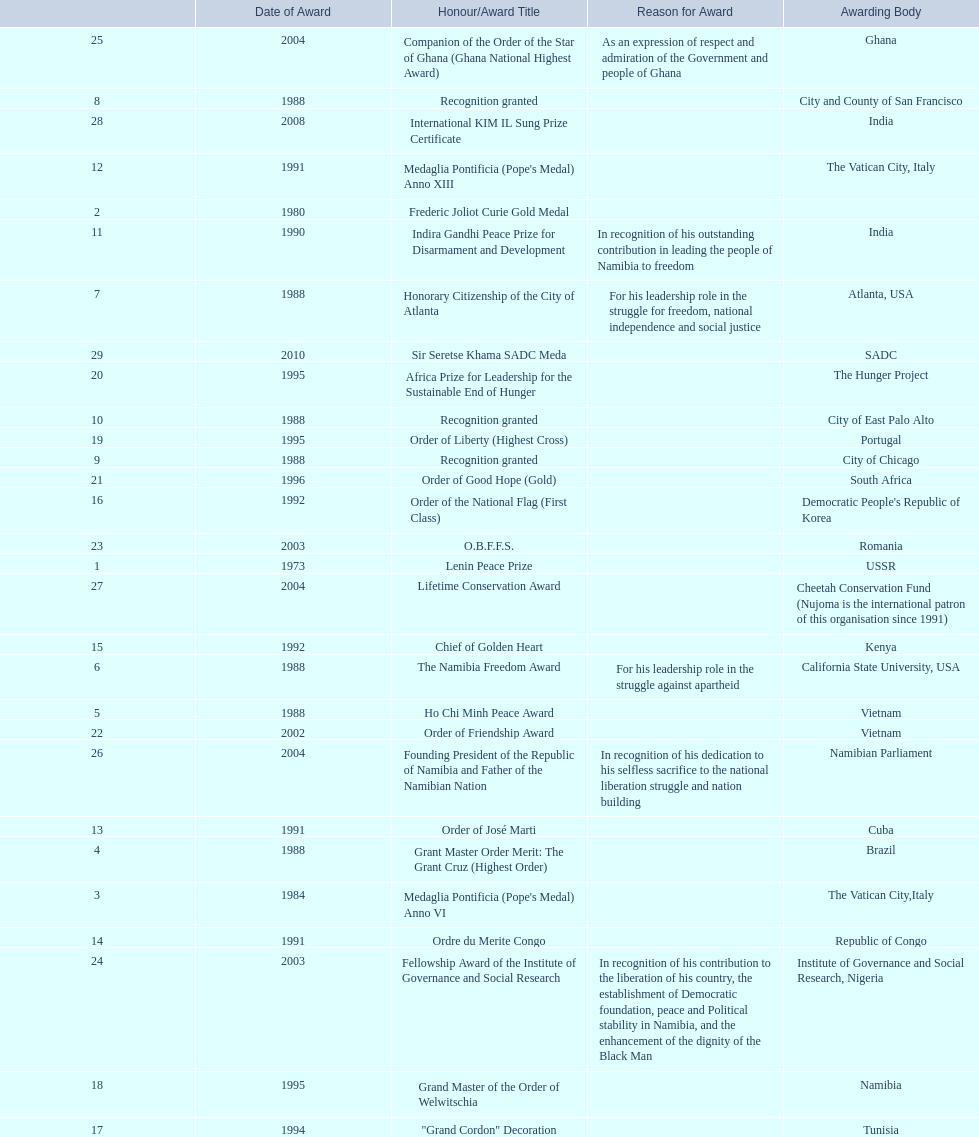Which awarding bodies have recognized sam nujoma? USSR, , The Vatican City,Italy, Brazil, Vietnam, California State University, USA, Atlanta, USA, City and County of San Francisco, City of Chicago, City of East Palo Alto, India, The Vatican City, Italy, Cuba, Republic of Congo, Kenya, Democratic People's Republic of Korea, Tunisia, Namibia, Portugal, The Hunger Project, South Africa, Vietnam, Romania, Institute of Governance and Social Research, Nigeria, Ghana, Namibian Parliament, Cheetah Conservation Fund (Nujoma is the international patron of this organisation since 1991), India, SADC. And what was the title of each award or honour? Lenin Peace Prize, Frederic Joliot Curie Gold Medal, Medaglia Pontificia (Pope's Medal) Anno VI, Grant Master Order Merit: The Grant Cruz (Highest Order), Ho Chi Minh Peace Award, The Namibia Freedom Award, Honorary Citizenship of the City of Atlanta, Recognition granted, Recognition granted, Recognition granted, Indira Gandhi Peace Prize for Disarmament and Development, Medaglia Pontificia (Pope's Medal) Anno XIII, Order of José Marti, Ordre du Merite Congo, Chief of Golden Heart, Order of the National Flag (First Class), "Grand Cordon" Decoration, Grand Master of the Order of Welwitschia, Order of Liberty (Highest Cross), Africa Prize for Leadership for the Sustainable End of Hunger, Order of Good Hope (Gold), Order of Friendship Award, O.B.F.F.S., Fellowship Award of the Institute of Governance and Social Research, Companion of the Order of the Star of Ghana (Ghana National Highest Award), Founding President of the Republic of Namibia and Father of the Namibian Nation, Lifetime Conservation Award, International KIM IL Sung Prize Certificate, Sir Seretse Khama SADC Meda. Of those, which nation awarded him the o.b.f.f.s.? Romania. 